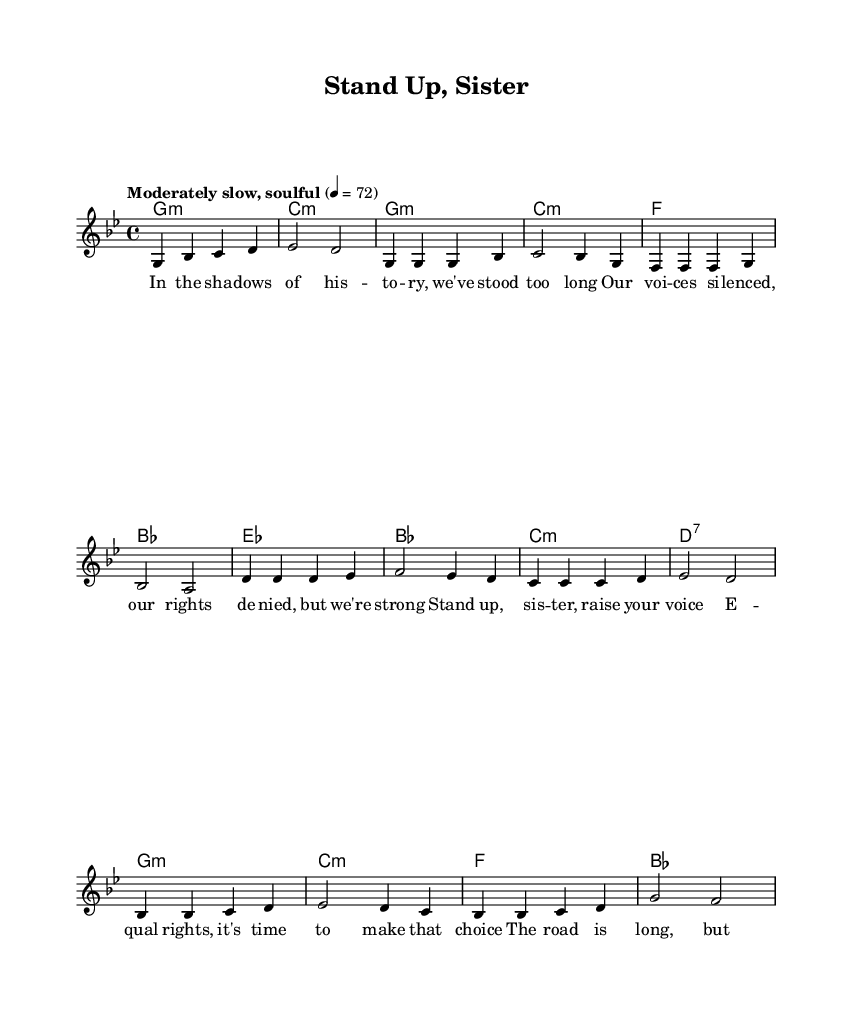What is the time signature of this music? The time signature is indicated at the beginning of the score and shows four beats per measure, represented as 4/4.
Answer: 4/4 What key is this piece composed in? The key signature is shown at the beginning of the music, indicating it is in G minor.
Answer: G minor How many measures are there in the chorus section? The chorus is made up of four measures, as counted from the notation for the chorus section in the music.
Answer: 4 What is the tempo marking for the piece? The tempo marking indicates the speed of the piece, which is specified as "Moderately slow, soulful," translating to a metronomic value of 72 beats per minute.
Answer: Moderately slow, soulful What is the primary thematic focus of the lyrics? The lyrics address women's rights and empowerment, prominently featuring calls for equality and solidarity in their struggle.
Answer: Women's rights and empowerment Give an example of a musical element that characterizes Rhythm and Blues style in this piece. The piece often features syncopated rhythms, back-beat emphasis, and expressive vocal lines, which are typical in Rhythm and Blues music.
Answer: Syncopated rhythms What is the last chord in the bridge section? The bridge ends with a chord that is identified clearly in the score, showing that the harmony resolves to f major.
Answer: f 